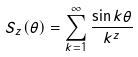<formula> <loc_0><loc_0><loc_500><loc_500>S _ { z } ( \theta ) = \sum _ { k = 1 } ^ { \infty } \frac { \sin k \theta } { k ^ { z } }</formula> 